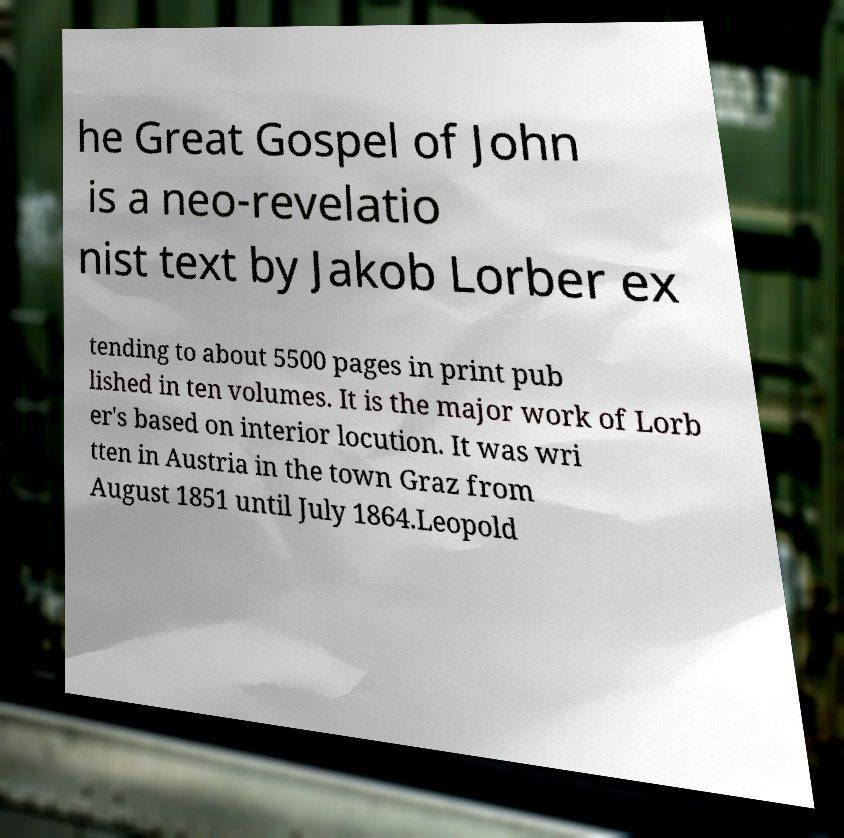There's text embedded in this image that I need extracted. Can you transcribe it verbatim? he Great Gospel of John is a neo-revelatio nist text by Jakob Lorber ex tending to about 5500 pages in print pub lished in ten volumes. It is the major work of Lorb er's based on interior locution. It was wri tten in Austria in the town Graz from August 1851 until July 1864.Leopold 